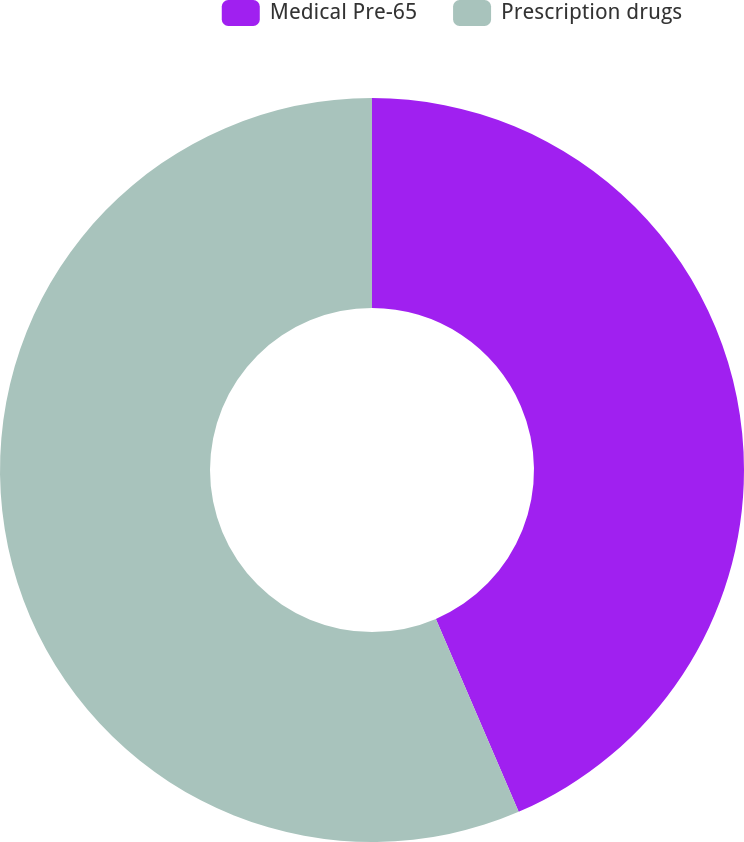Convert chart to OTSL. <chart><loc_0><loc_0><loc_500><loc_500><pie_chart><fcel>Medical Pre-65<fcel>Prescription drugs<nl><fcel>43.55%<fcel>56.45%<nl></chart> 